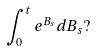<formula> <loc_0><loc_0><loc_500><loc_500>\int _ { 0 } ^ { t } e ^ { B _ { s } } d B _ { s } ?</formula> 